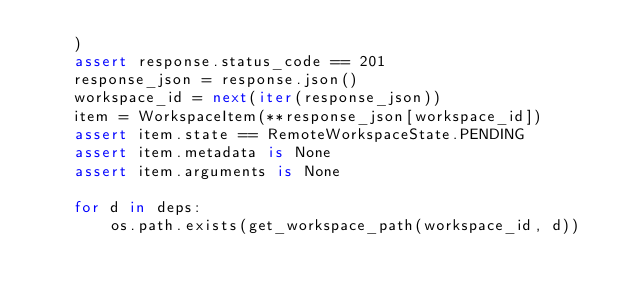<code> <loc_0><loc_0><loc_500><loc_500><_Python_>    )
    assert response.status_code == 201
    response_json = response.json()
    workspace_id = next(iter(response_json))
    item = WorkspaceItem(**response_json[workspace_id])
    assert item.state == RemoteWorkspaceState.PENDING
    assert item.metadata is None
    assert item.arguments is None

    for d in deps:
        os.path.exists(get_workspace_path(workspace_id, d))
</code> 